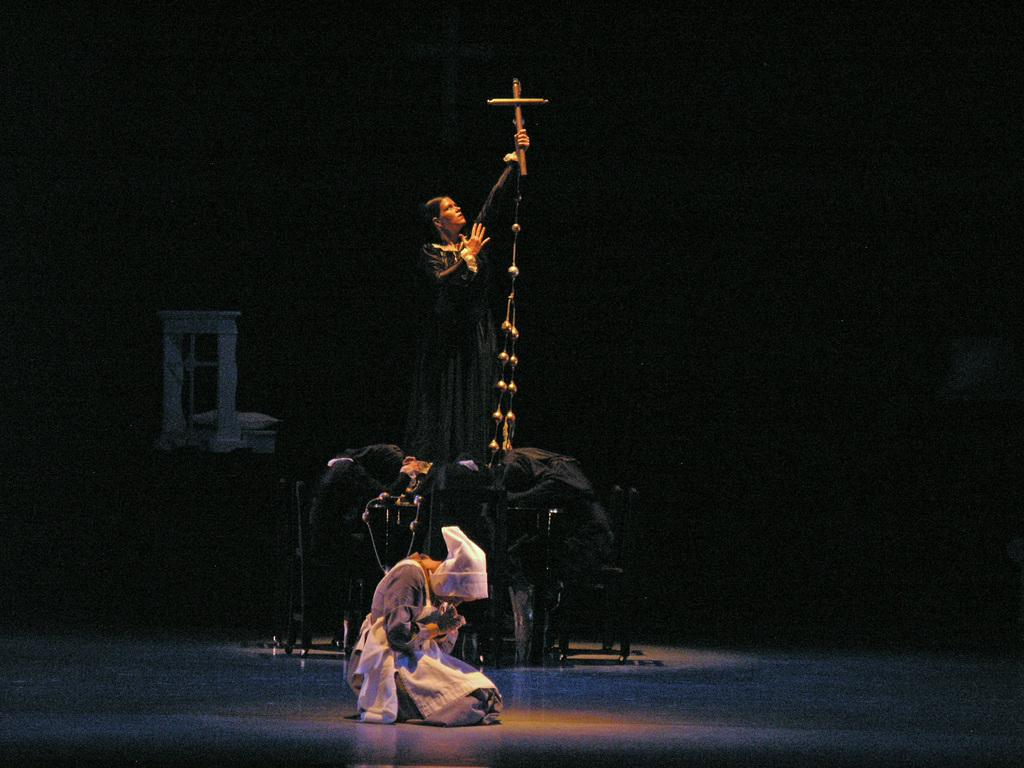How many people are in the image? There are people in the image, but the exact number is not specified. Can you describe the lady in the center of the image? The lady in the center of the image is standing and holding a cross. What can be seen beneath the people in the image? There is a floor visible in the image. What trick did the lady perform with the cross in the image? There is no indication in the image that the lady performed any trick with the cross. 